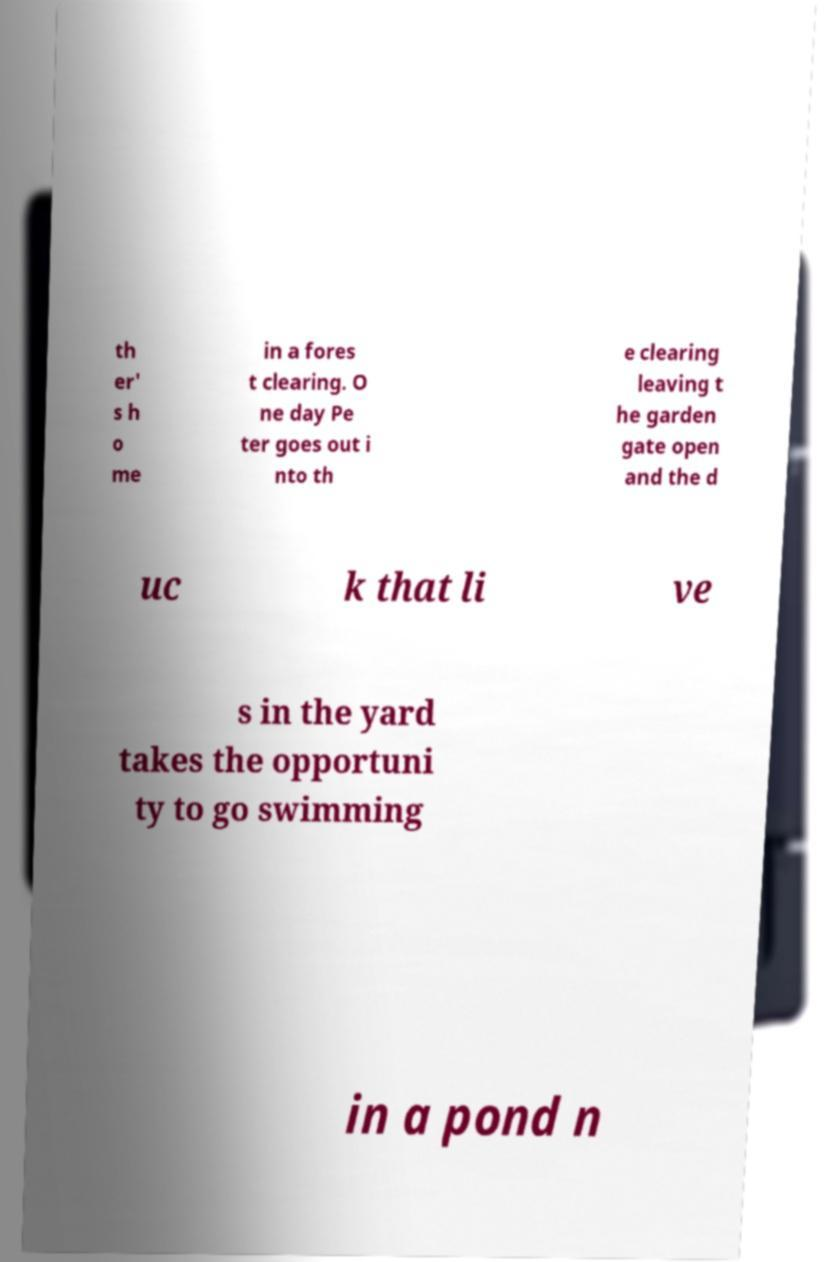Can you accurately transcribe the text from the provided image for me? th er' s h o me in a fores t clearing. O ne day Pe ter goes out i nto th e clearing leaving t he garden gate open and the d uc k that li ve s in the yard takes the opportuni ty to go swimming in a pond n 